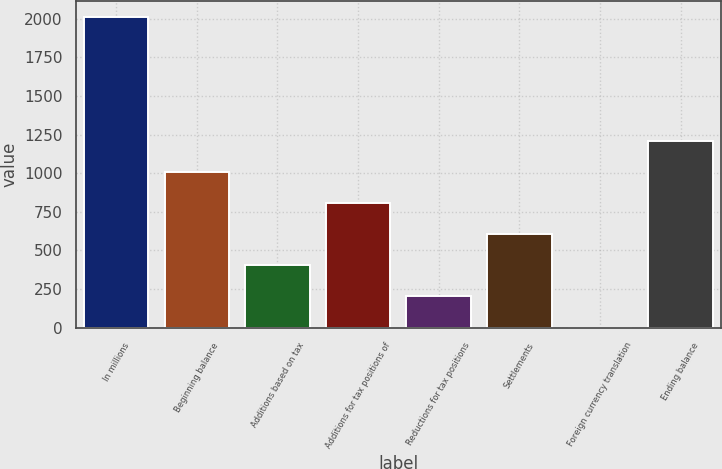Convert chart. <chart><loc_0><loc_0><loc_500><loc_500><bar_chart><fcel>In millions<fcel>Beginning balance<fcel>Additions based on tax<fcel>Additions for tax positions of<fcel>Reductions for tax positions<fcel>Settlements<fcel>Foreign currency translation<fcel>Ending balance<nl><fcel>2013<fcel>1007<fcel>403.4<fcel>805.8<fcel>202.2<fcel>604.6<fcel>1<fcel>1208.2<nl></chart> 